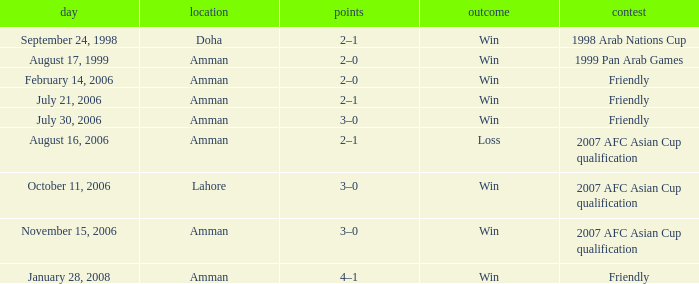Which competition took place on October 11, 2006? 2007 AFC Asian Cup qualification. 